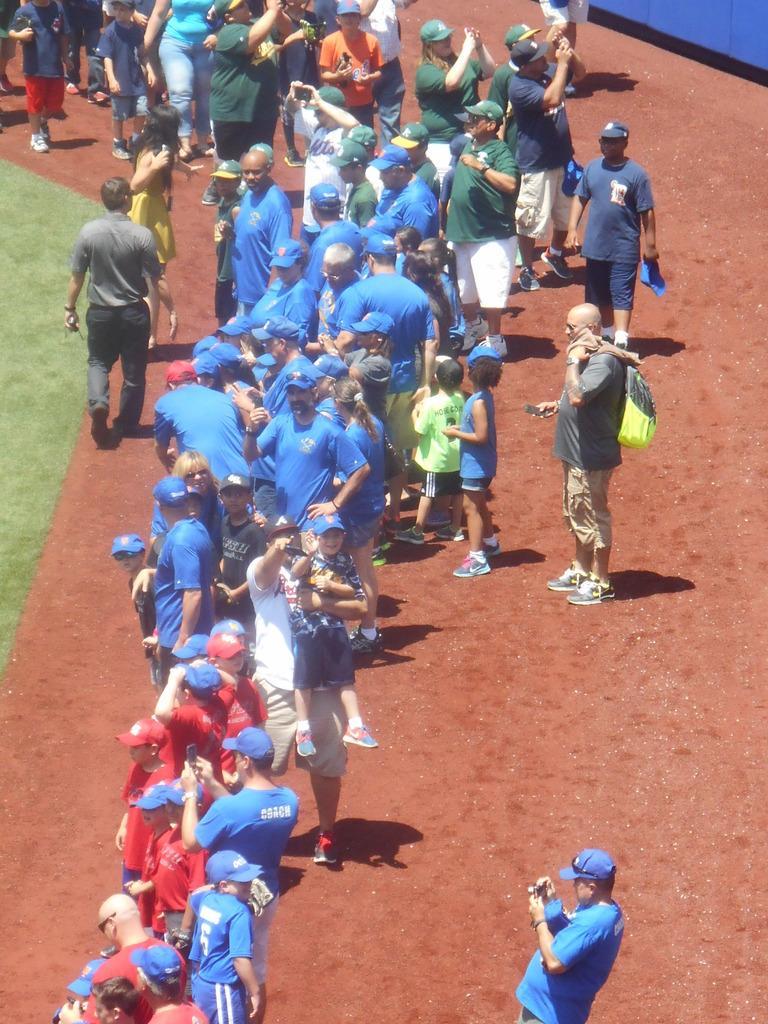Could you give a brief overview of what you see in this image? This image is taken outdoors. At the bottom of the image there is a ground. In the middle of the image many people are standing on the ground and a few are holding mobile phones in their hands. On the left side of the image there is a ground with grass on it and a man is walking on the ground. 